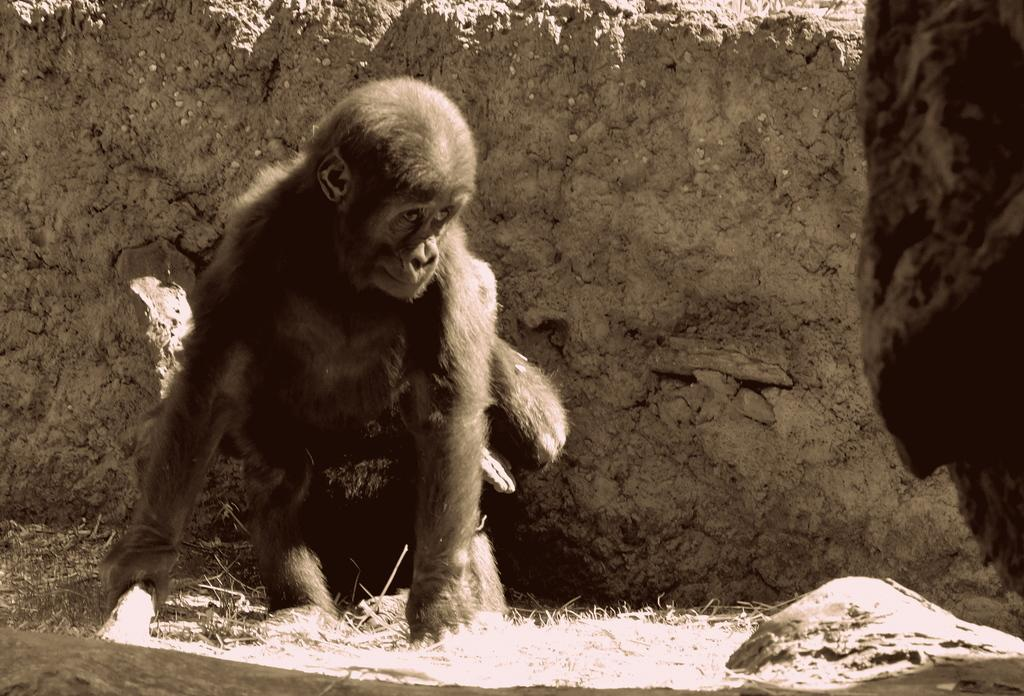What is the color scheme of the image? The image is black and white. What animal can be seen in the image? There is a monkey in the image. Where is the monkey located in the image? The monkey is on the ground. How many frames are present in the image? The image is not a series of frames, so it is not possible to determine the number of frames. Is there a goat visible in the image? No, there is no goat present in the image; it features a monkey on the ground. 